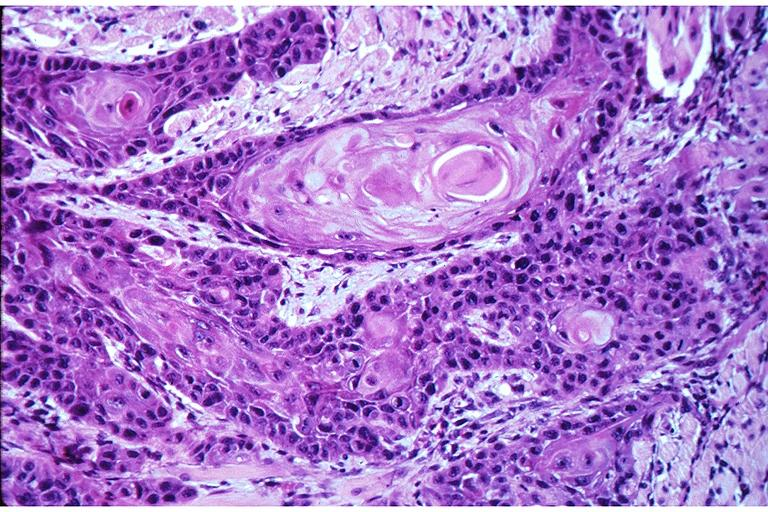does retroperitoneal leiomyosarcoma show squamous cell carcinoma?
Answer the question using a single word or phrase. No 